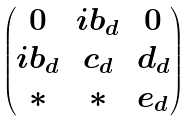<formula> <loc_0><loc_0><loc_500><loc_500>\begin{pmatrix} 0 & i b _ { d } & 0 \\ i b _ { d } & c _ { d } & d _ { d } \\ * & * & e _ { d } \end{pmatrix}</formula> 